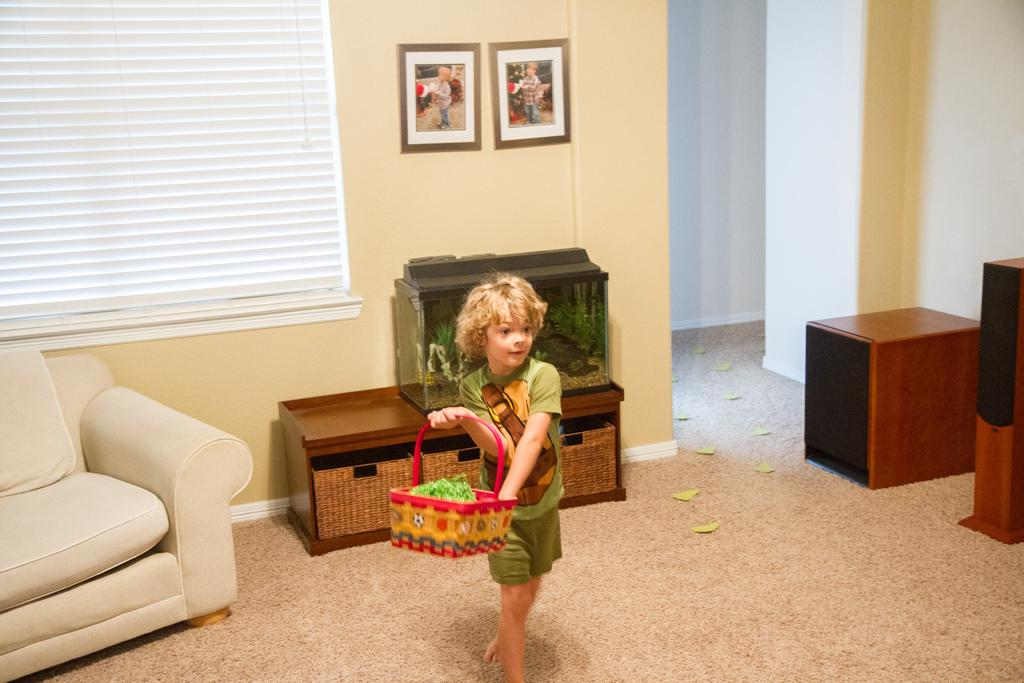What is the main subject of the image? The main subject of the image is a boy standing in the center. What is the boy holding in the image? The boy is holding a basket. What can be seen in the background of the image? In the background, there is a window, a couch, a table, an aquarium, a photo frame, a speaker, a wall, and a pillar. What type of question is the crow asking in the image? There is no crow present in the image, and therefore no such interaction can be observed. 